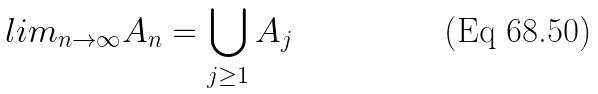Convert formula to latex. <formula><loc_0><loc_0><loc_500><loc_500>l i m _ { n \rightarrow \infty } A _ { n } = \bigcup _ { j \geq 1 } A _ { j }</formula> 